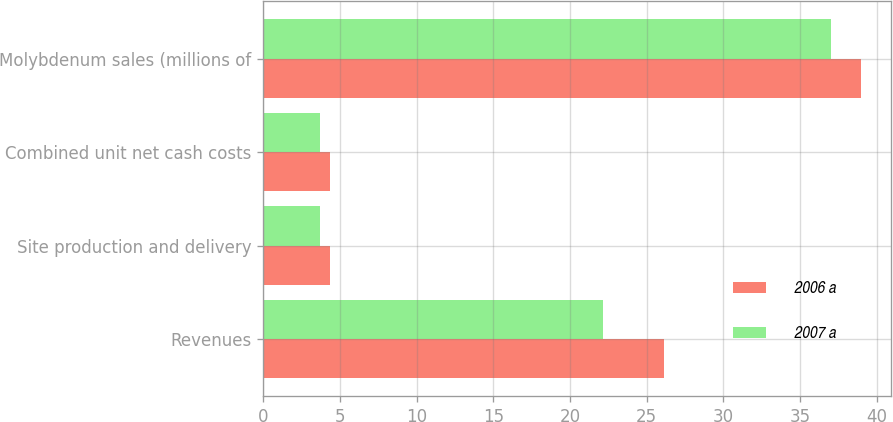Convert chart. <chart><loc_0><loc_0><loc_500><loc_500><stacked_bar_chart><ecel><fcel>Revenues<fcel>Site production and delivery<fcel>Combined unit net cash costs<fcel>Molybdenum sales (millions of<nl><fcel>2006 a<fcel>26.1<fcel>4.32<fcel>4.32<fcel>39<nl><fcel>2007 a<fcel>22.14<fcel>3.71<fcel>3.71<fcel>37<nl></chart> 